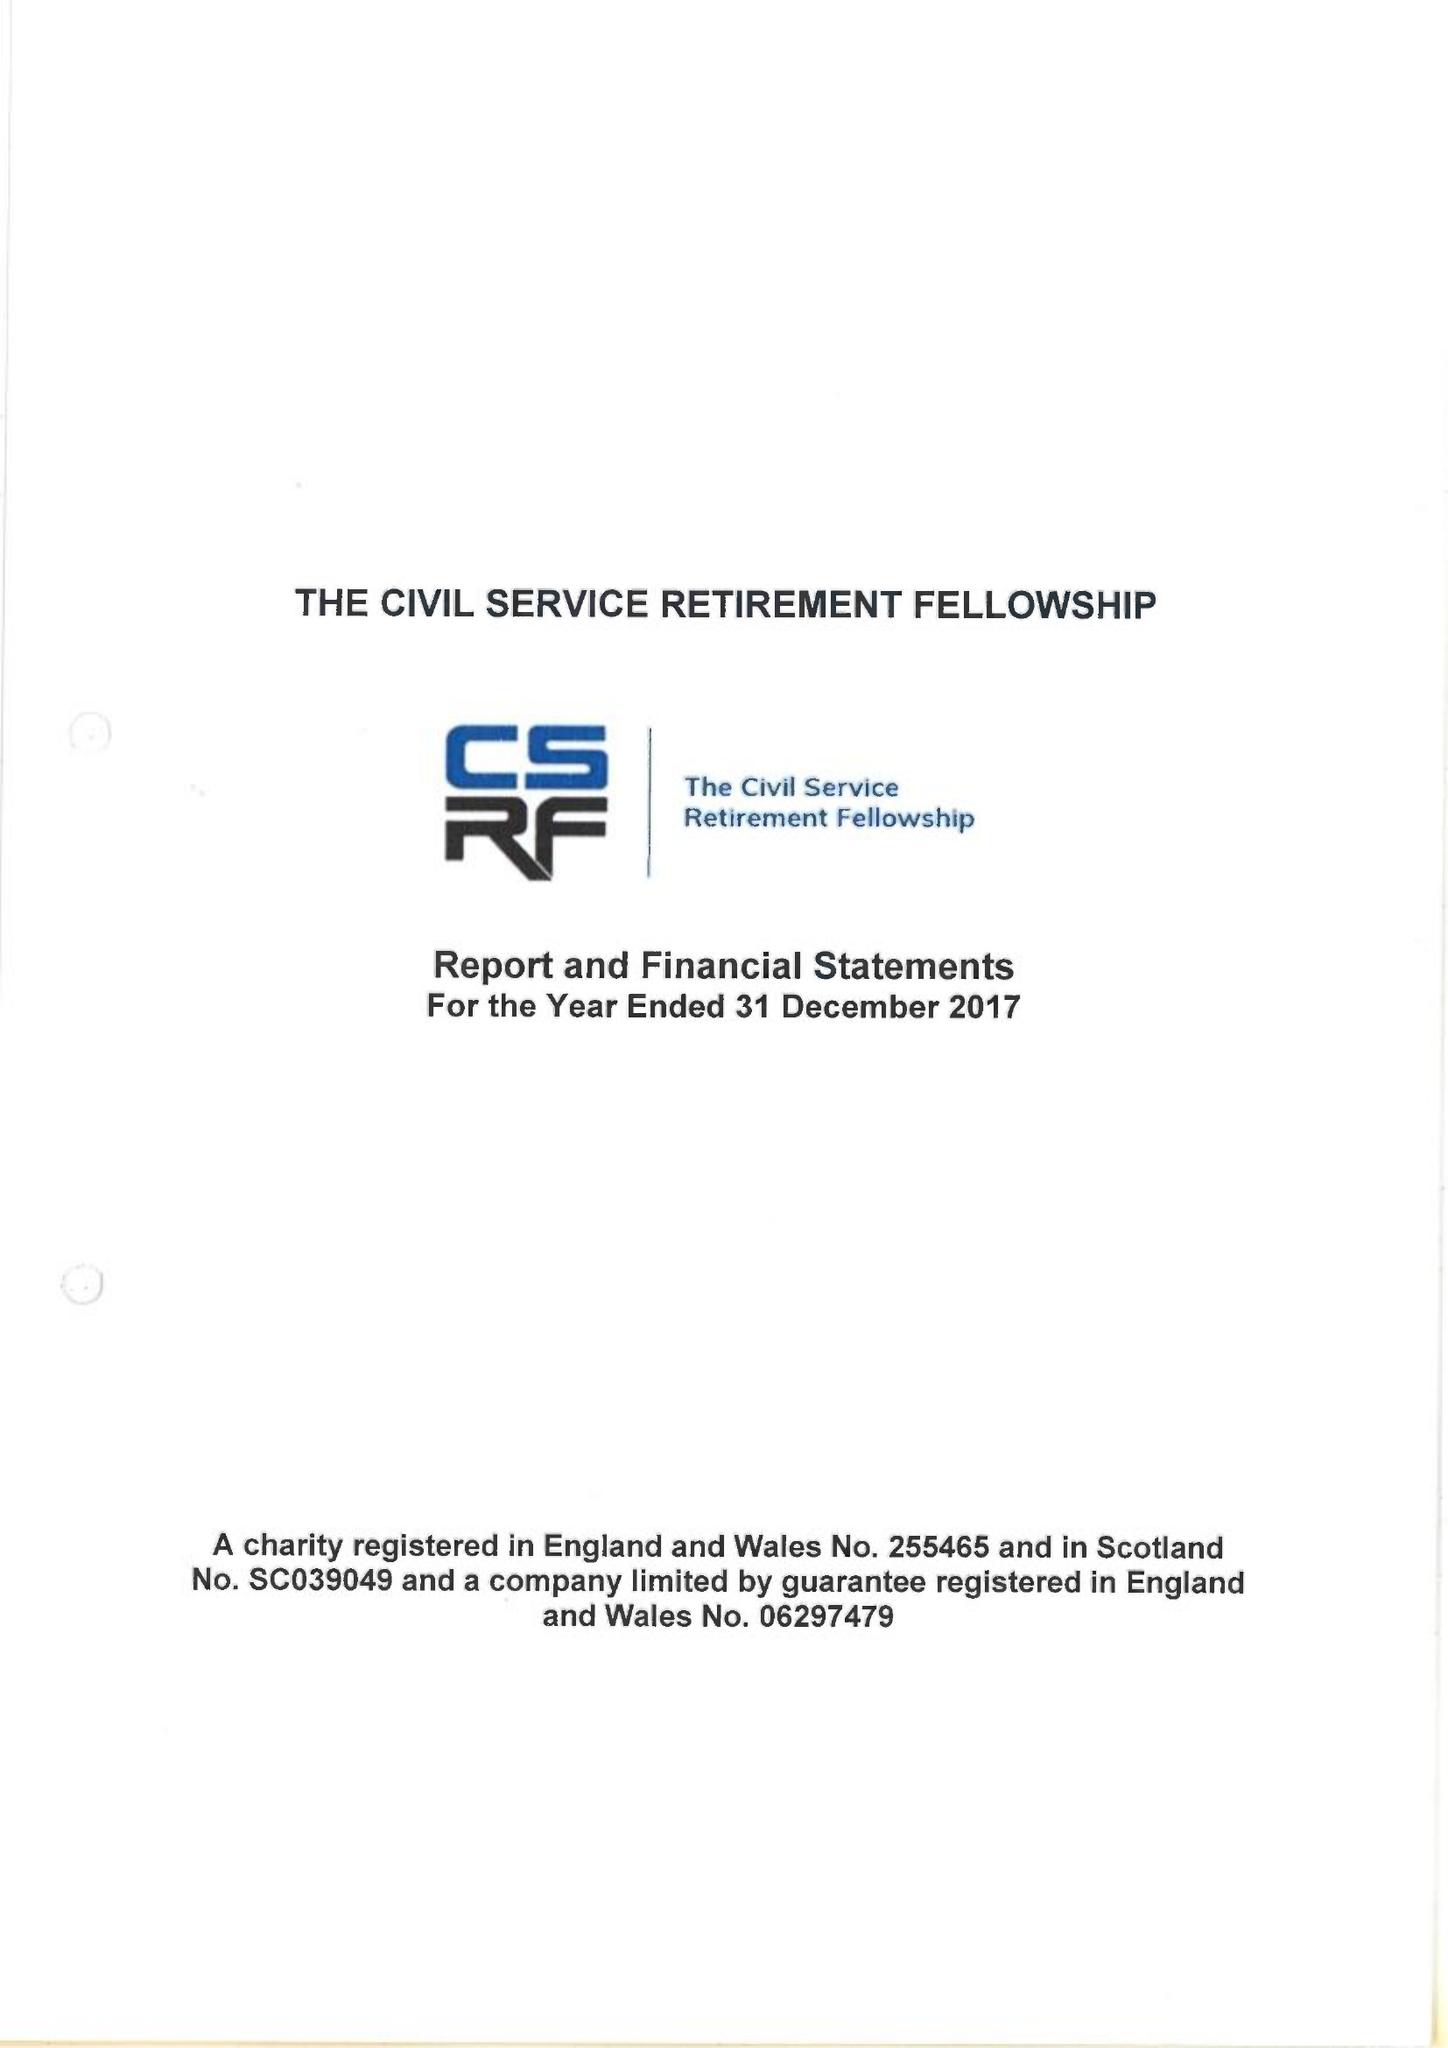What is the value for the spending_annually_in_british_pounds?
Answer the question using a single word or phrase. 272894.00 